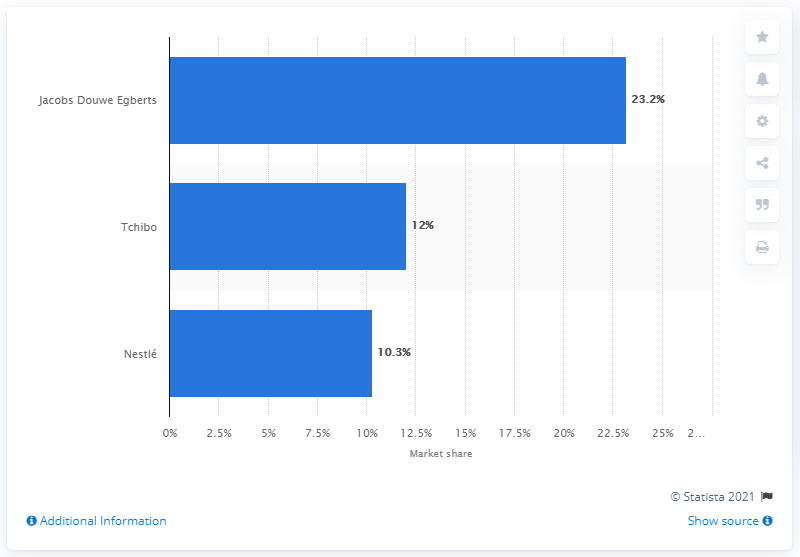Draw attention to some important aspects in this diagram. Tchibo's market share in the German coffee market in 2016 was approximately 12%. 